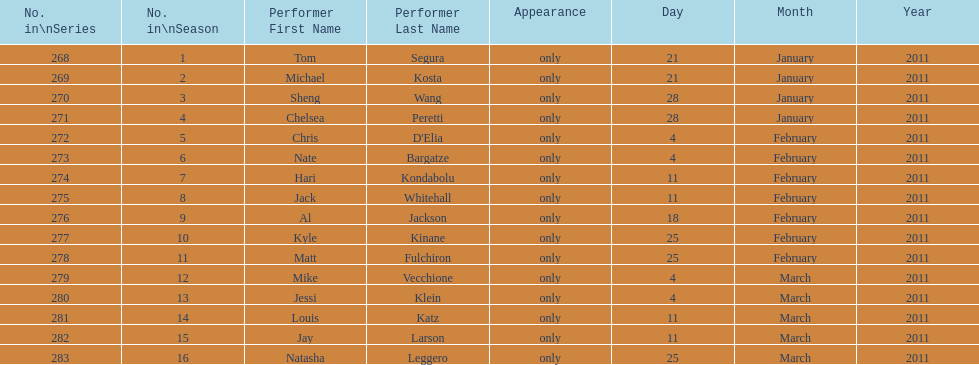How many weeks did season 15 of comedy central presents span? 9. 